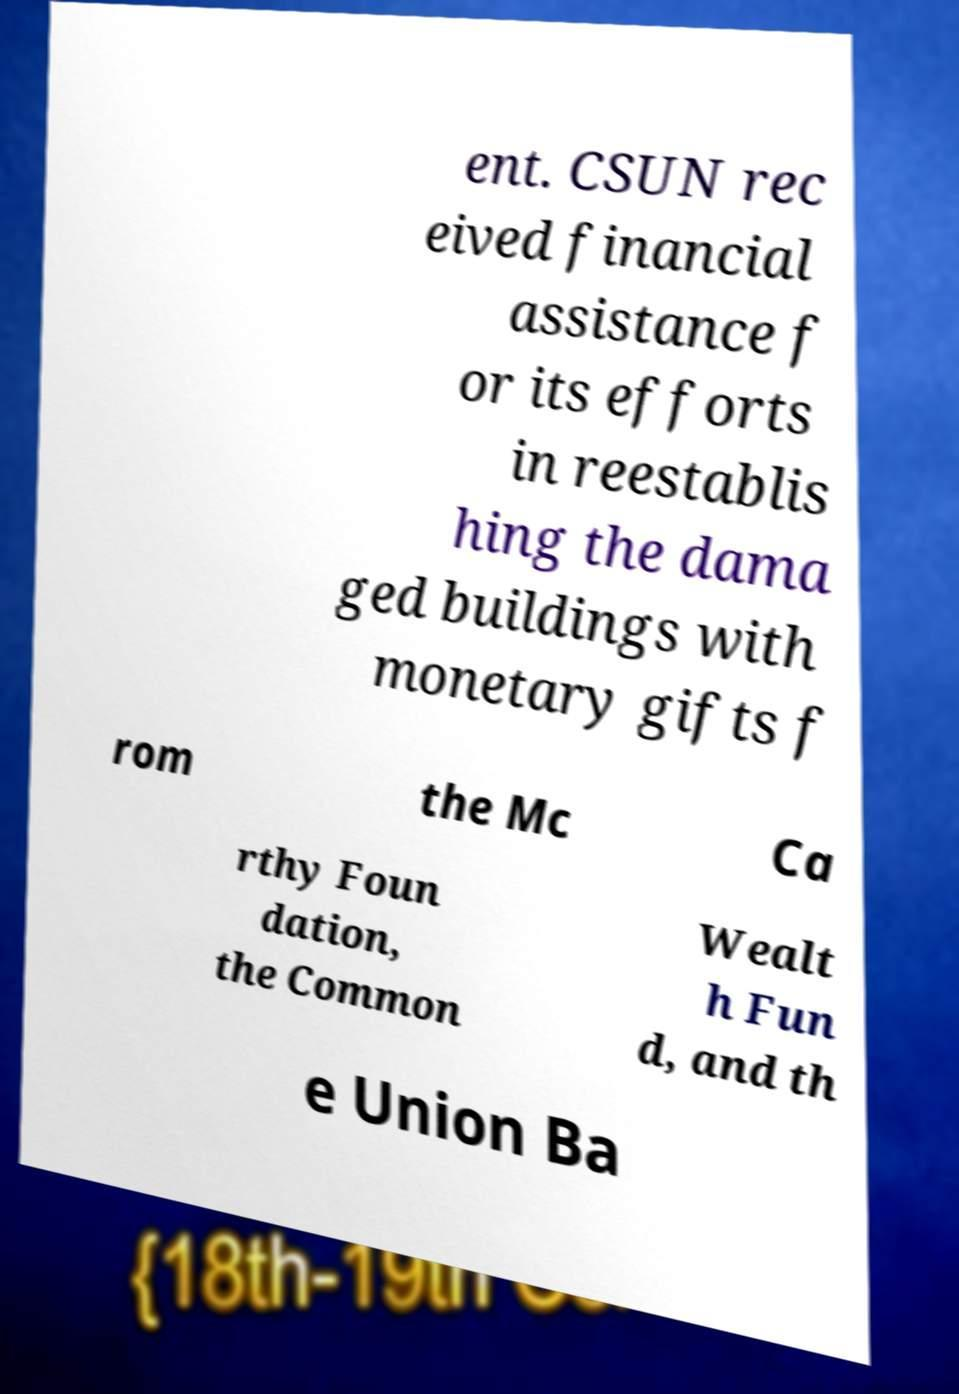There's text embedded in this image that I need extracted. Can you transcribe it verbatim? ent. CSUN rec eived financial assistance f or its efforts in reestablis hing the dama ged buildings with monetary gifts f rom the Mc Ca rthy Foun dation, the Common Wealt h Fun d, and th e Union Ba 